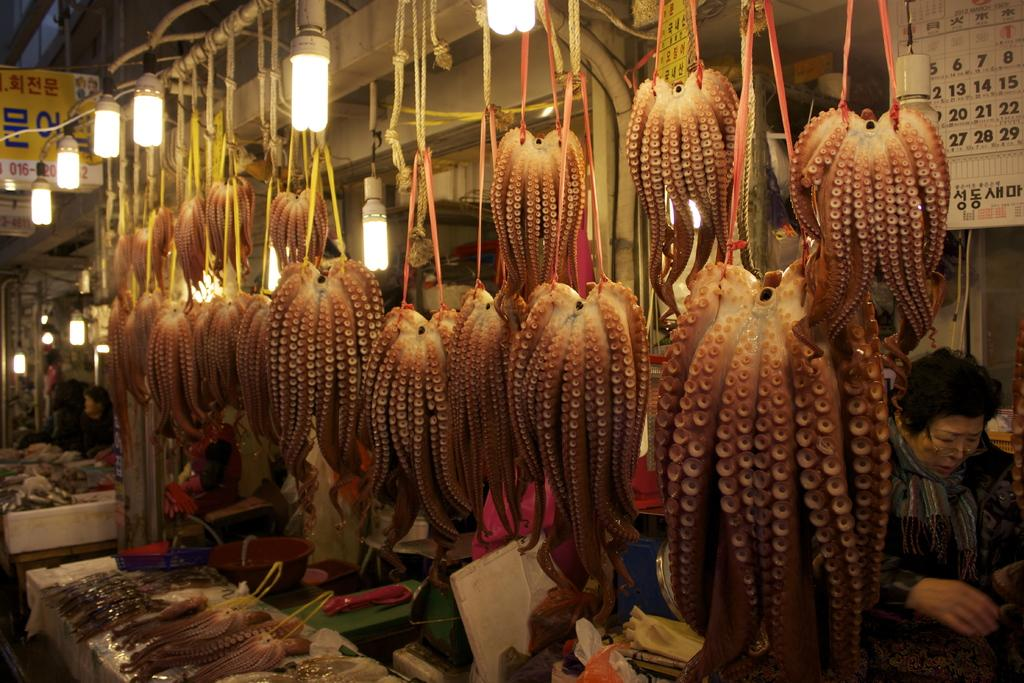What is the main subject of the image? There is an octopus in the image. How is the octopus positioned in the image? The octopus is hanging with ropes. What can be seen on the right side of the image? There are lights on the right side of the image. Are there any people in the image? Yes, there is a woman in the image. What theory does the woman in the image propose about the octopus? There is no indication in the image that the woman is proposing a theory about the octopus. Can you see a hammer in the image? No, there is no hammer present in the image. 